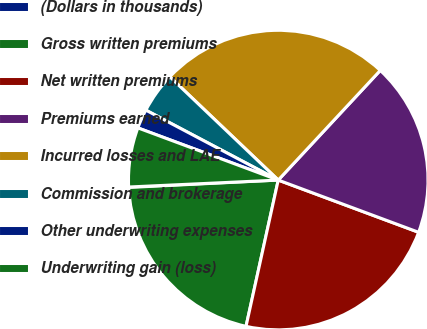Convert chart to OTSL. <chart><loc_0><loc_0><loc_500><loc_500><pie_chart><fcel>(Dollars in thousands)<fcel>Gross written premiums<fcel>Net written premiums<fcel>Premiums earned<fcel>Incurred losses and LAE<fcel>Commission and brokerage<fcel>Other underwriting expenses<fcel>Underwriting gain (loss)<nl><fcel>0.05%<fcel>20.76%<fcel>22.78%<fcel>18.74%<fcel>24.81%<fcel>4.38%<fcel>2.07%<fcel>6.4%<nl></chart> 